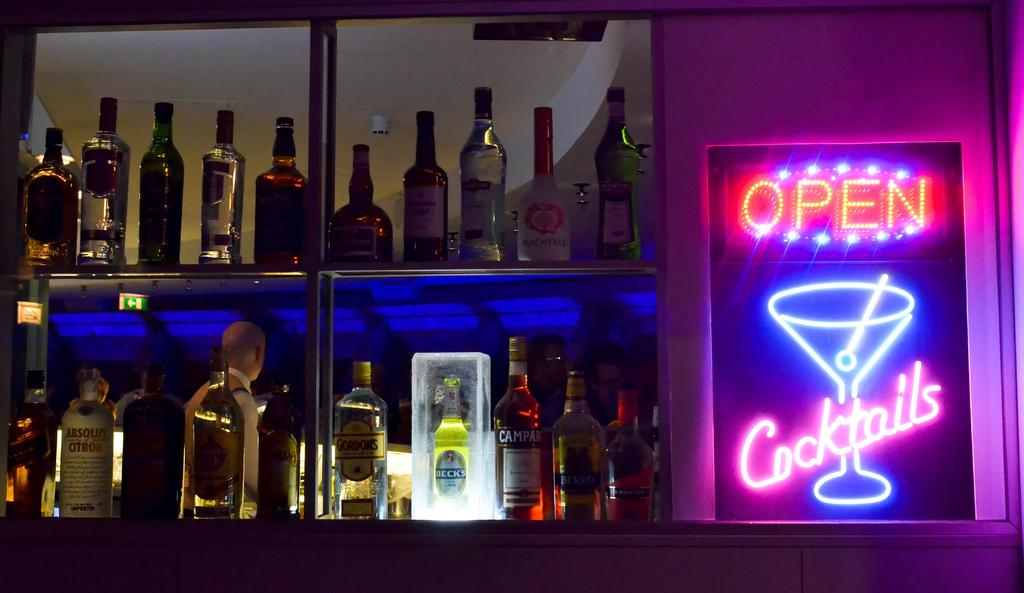<image>
Provide a brief description of the given image. A bar has a neon sign next to it that says it is open for cocktails. 